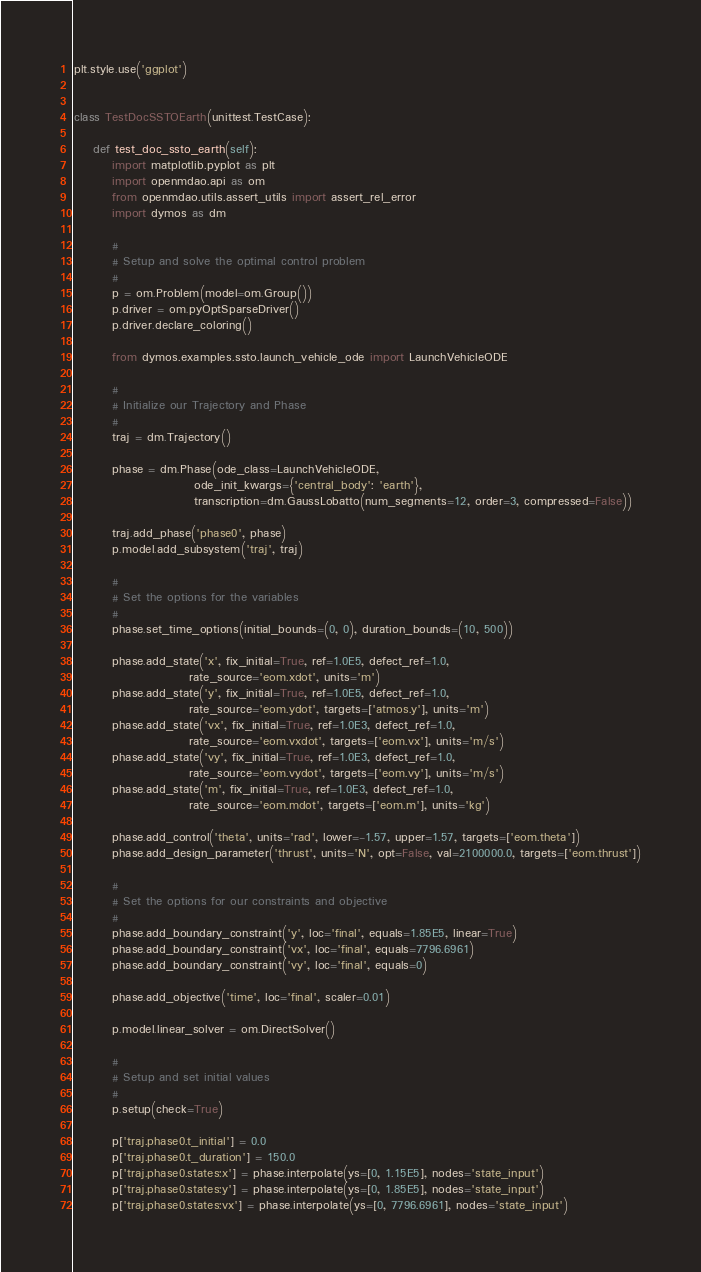<code> <loc_0><loc_0><loc_500><loc_500><_Python_>plt.style.use('ggplot')


class TestDocSSTOEarth(unittest.TestCase):

    def test_doc_ssto_earth(self):
        import matplotlib.pyplot as plt
        import openmdao.api as om
        from openmdao.utils.assert_utils import assert_rel_error
        import dymos as dm

        #
        # Setup and solve the optimal control problem
        #
        p = om.Problem(model=om.Group())
        p.driver = om.pyOptSparseDriver()
        p.driver.declare_coloring()

        from dymos.examples.ssto.launch_vehicle_ode import LaunchVehicleODE

        #
        # Initialize our Trajectory and Phase
        #
        traj = dm.Trajectory()

        phase = dm.Phase(ode_class=LaunchVehicleODE,
                         ode_init_kwargs={'central_body': 'earth'},
                         transcription=dm.GaussLobatto(num_segments=12, order=3, compressed=False))

        traj.add_phase('phase0', phase)
        p.model.add_subsystem('traj', traj)

        #
        # Set the options for the variables
        #
        phase.set_time_options(initial_bounds=(0, 0), duration_bounds=(10, 500))

        phase.add_state('x', fix_initial=True, ref=1.0E5, defect_ref=1.0,
                        rate_source='eom.xdot', units='m')
        phase.add_state('y', fix_initial=True, ref=1.0E5, defect_ref=1.0,
                        rate_source='eom.ydot', targets=['atmos.y'], units='m')
        phase.add_state('vx', fix_initial=True, ref=1.0E3, defect_ref=1.0,
                        rate_source='eom.vxdot', targets=['eom.vx'], units='m/s')
        phase.add_state('vy', fix_initial=True, ref=1.0E3, defect_ref=1.0,
                        rate_source='eom.vydot', targets=['eom.vy'], units='m/s')
        phase.add_state('m', fix_initial=True, ref=1.0E3, defect_ref=1.0,
                        rate_source='eom.mdot', targets=['eom.m'], units='kg')

        phase.add_control('theta', units='rad', lower=-1.57, upper=1.57, targets=['eom.theta'])
        phase.add_design_parameter('thrust', units='N', opt=False, val=2100000.0, targets=['eom.thrust'])

        #
        # Set the options for our constraints and objective
        #
        phase.add_boundary_constraint('y', loc='final', equals=1.85E5, linear=True)
        phase.add_boundary_constraint('vx', loc='final', equals=7796.6961)
        phase.add_boundary_constraint('vy', loc='final', equals=0)

        phase.add_objective('time', loc='final', scaler=0.01)

        p.model.linear_solver = om.DirectSolver()

        #
        # Setup and set initial values
        #
        p.setup(check=True)

        p['traj.phase0.t_initial'] = 0.0
        p['traj.phase0.t_duration'] = 150.0
        p['traj.phase0.states:x'] = phase.interpolate(ys=[0, 1.15E5], nodes='state_input')
        p['traj.phase0.states:y'] = phase.interpolate(ys=[0, 1.85E5], nodes='state_input')
        p['traj.phase0.states:vx'] = phase.interpolate(ys=[0, 7796.6961], nodes='state_input')</code> 